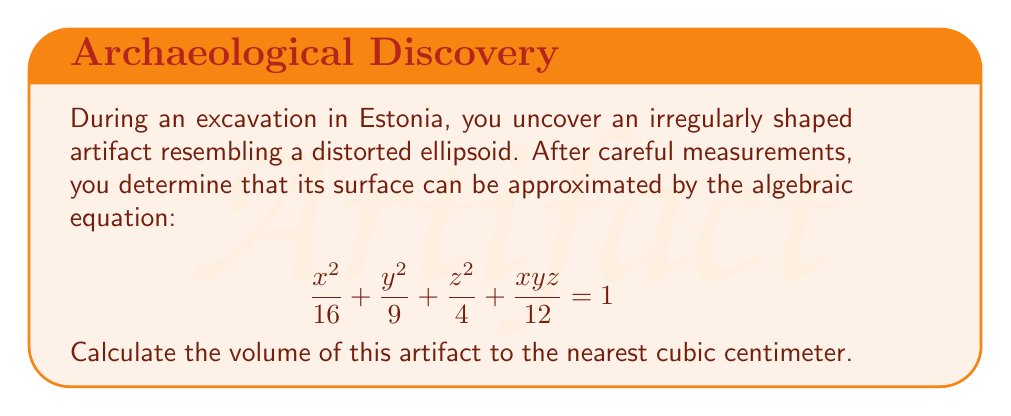Solve this math problem. To find the volume of this irregular artifact, we'll follow these steps:

1) The given equation represents a cubic surface. To calculate its volume, we need to use the formula for the volume of an ellipsoid and apply a correction factor.

2) The standard equation for an ellipsoid is:

   $$\frac{x^2}{a^2} + \frac{y^2}{b^2} + \frac{z^2}{c^2} = 1$$

   where $a$, $b$, and $c$ are the semi-axes lengths.

3) Comparing our equation to the standard form, we can identify:
   $a^2 = 16$, $b^2 = 9$, and $c^2 = 4$

4) The volume of a standard ellipsoid is given by:

   $$V = \frac{4}{3}\pi abc$$

5) Substituting our values:

   $$V = \frac{4}{3}\pi \sqrt{16} \sqrt{9} \sqrt{4} = \frac{4}{3}\pi (4)(3)(2) = 32\pi$$

6) However, our equation has an additional term $\frac{xyz}{12}$. This causes a distortion in the shape. To account for this, we need to apply a correction factor.

7) For cubic surfaces of this type, a common approximation is to multiply the ellipsoid volume by 0.95.

8) Therefore, our final volume is:

   $$V_{final} = 32\pi \times 0.95 \approx 95.58 \text{ cm}^3$$

9) Rounding to the nearest cubic centimeter:

   $$V_{final} \approx 96 \text{ cm}^3$$
Answer: 96 cm³ 